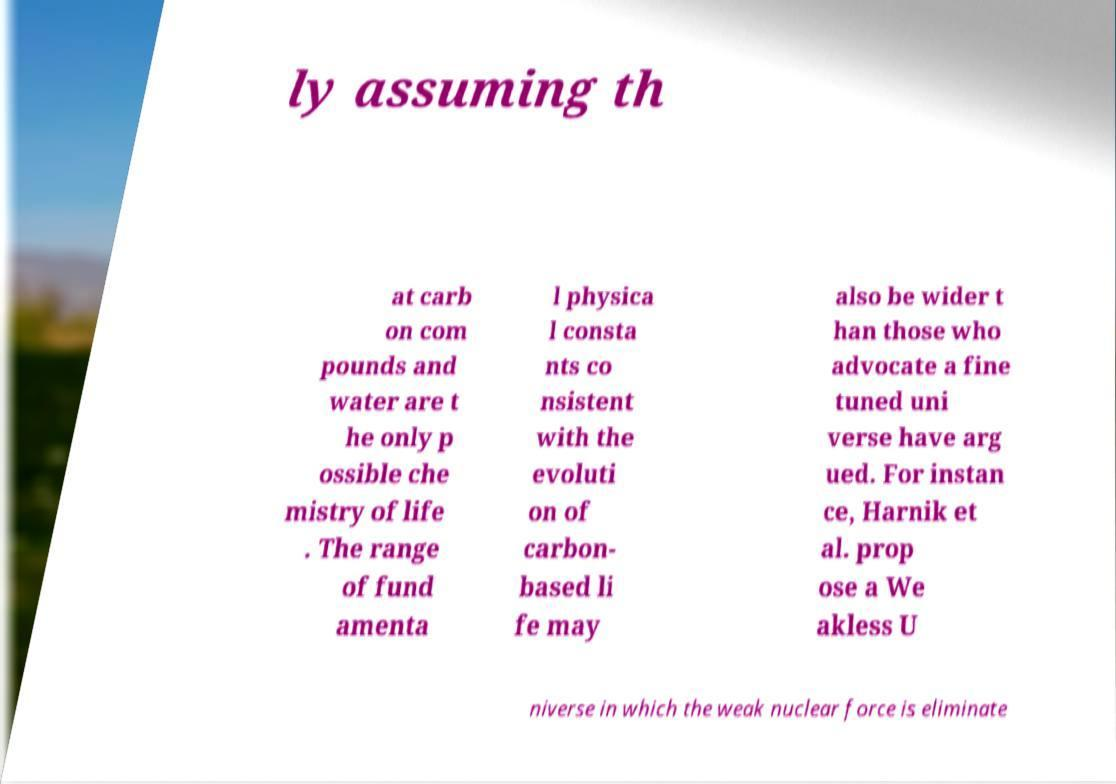Could you extract and type out the text from this image? ly assuming th at carb on com pounds and water are t he only p ossible che mistry of life . The range of fund amenta l physica l consta nts co nsistent with the evoluti on of carbon- based li fe may also be wider t han those who advocate a fine tuned uni verse have arg ued. For instan ce, Harnik et al. prop ose a We akless U niverse in which the weak nuclear force is eliminate 